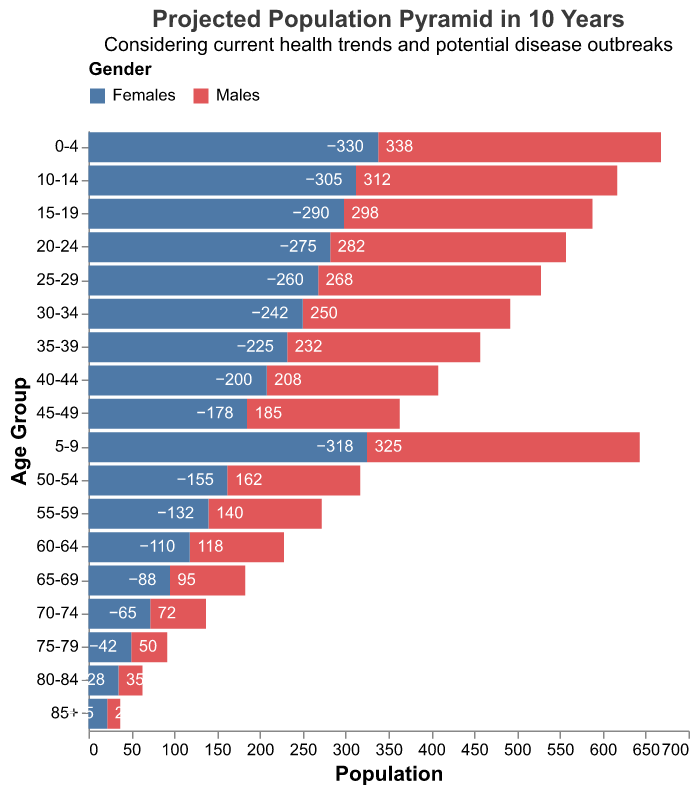What is the title of the figure? The title of the figure is located at the top and describes the subject of the visual representation.
Answer: Projected Population Pyramid in 10 Years How many males are projected to be in the 0-4 age group? Referring to the figure, we see the projection for males in the 0-4 age group represents the left bar, with the numerical value indicated.
Answer: 330 In which age group are the projected female population highest? By scanning through the heights of the bars representing females (right bars), the 0-4 age group has the highest value.
Answer: 0-4 What is the total projected population for the age group 10-14? Add the population of males and females in the 10-14 age group: 305 (males) + 312 (females).
Answer: 617 How does the projected population of males and females in the 65-69 age group compare? Compare the length of the bars and the numerical values: 88 (males) vs. 95 (females).
Answer: Females are higher by 7 What is the difference between the number of projected males and females in the 20-24 age group? Subtract the number of males from females in the 20-24 age group: 282 (females) - 275 (males).
Answer: 7 Which gender has a higher projected population in the 75-79 age group? Examine the lengths of the bars for the 75-79 age group: the female bar is longer.
Answer: Females What is the projected male population for the age group 45-49? By looking at the figure, the male population for this age group is represented on the left side.
Answer: 178 Is the population of males or females higher in the 80-84 age group? Comparing the left and right bar lengths for the 80-84 age group, the female bar is longer.
Answer: Females Considering the current trends and potential disease outbreaks, which age group might need more medical resources in the future based on population? Given the highest populations shown for the youngest (0-4) and progressively larger younger age groups, these may need more resources due to higher counts and vulnerability to diseases.
Answer: 0-4 and younger age groups 